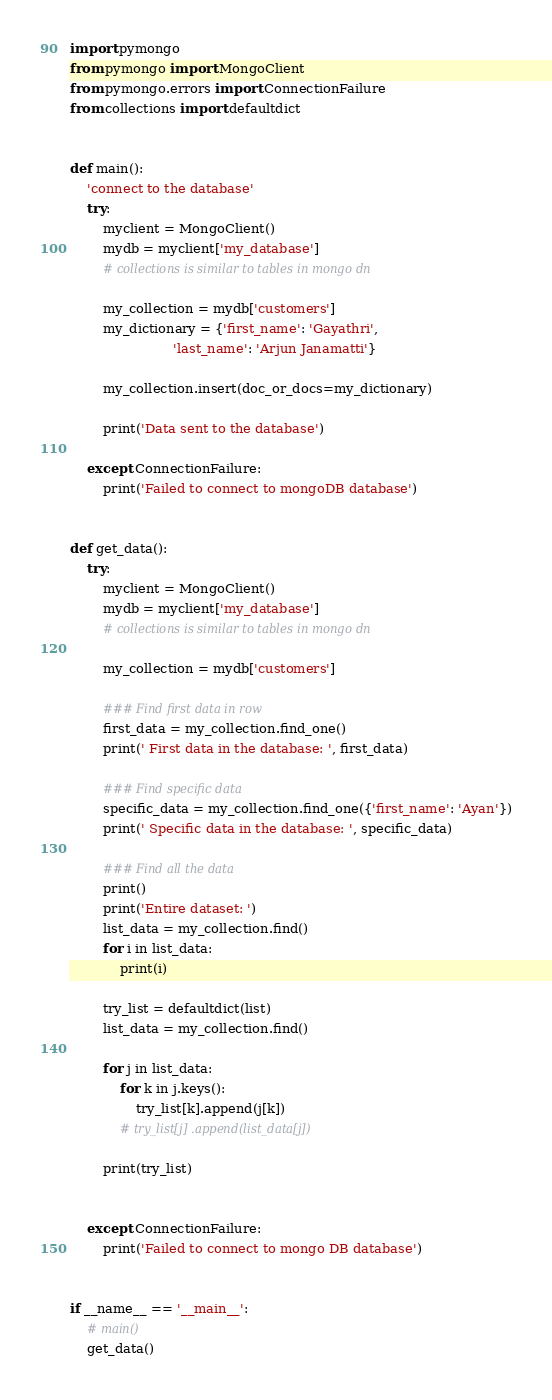<code> <loc_0><loc_0><loc_500><loc_500><_Python_>import pymongo
from pymongo import MongoClient
from pymongo.errors import ConnectionFailure
from collections import defaultdict


def main():
    'connect to the database'
    try:
        myclient = MongoClient()
        mydb = myclient['my_database']
        # collections is similar to tables in mongo dn

        my_collection = mydb['customers']
        my_dictionary = {'first_name': 'Gayathri',
                         'last_name': 'Arjun Janamatti'}

        my_collection.insert(doc_or_docs=my_dictionary)

        print('Data sent to the database')

    except ConnectionFailure:
        print('Failed to connect to mongoDB database')


def get_data():
    try:
        myclient = MongoClient()
        mydb = myclient['my_database']
        # collections is similar to tables in mongo dn

        my_collection = mydb['customers']

        ### Find first data in row
        first_data = my_collection.find_one()
        print(' First data in the database: ', first_data)

        ### Find specific data
        specific_data = my_collection.find_one({'first_name': 'Ayan'})
        print(' Specific data in the database: ', specific_data)

        ### Find all the data
        print()
        print('Entire dataset: ')
        list_data = my_collection.find()
        for i in list_data:
            print(i)

        try_list = defaultdict(list)
        list_data = my_collection.find()

        for j in list_data:
            for k in j.keys():
                try_list[k].append(j[k])
            # try_list[j] .append(list_data[j])

        print(try_list)


    except ConnectionFailure:
        print('Failed to connect to mongo DB database')


if __name__ == '__main__':
    # main()
    get_data()</code> 